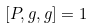Convert formula to latex. <formula><loc_0><loc_0><loc_500><loc_500>[ P , g , g ] = 1</formula> 